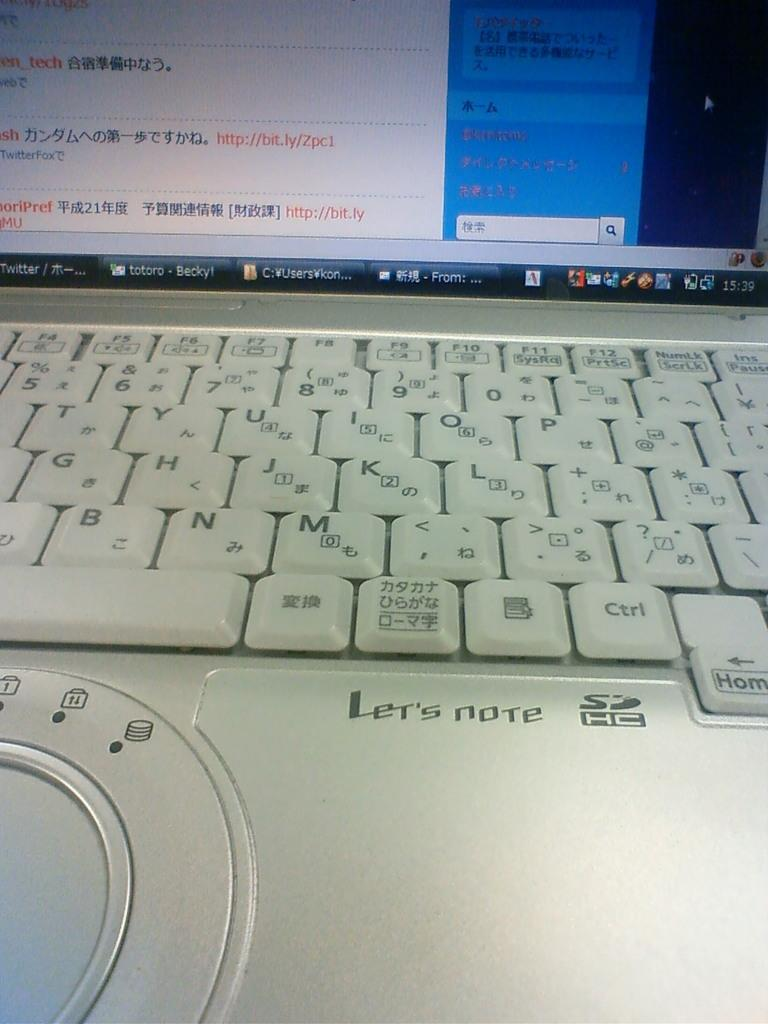What electronic device is visible in the image? There is a laptop in the image. How is the laptop depicted in the image? The laptop appears to be truncated. What type of sign can be seen near the laptop in the image? There is no sign present in the image; it only features a laptop that appears to be truncated. Can you tell me how many times the laptop was kicked before the image was taken? There is no indication in the image that the laptop was kicked, and therefore no such information can be determined. 